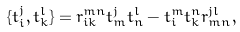<formula> <loc_0><loc_0><loc_500><loc_500>\{ t _ { i } ^ { j } , t _ { k } ^ { l } \} = r _ { i k } ^ { m n } t _ { m } ^ { j } t _ { n } ^ { l } - t _ { i } ^ { m } t _ { k } ^ { n } r _ { m n } ^ { j l } ,</formula> 